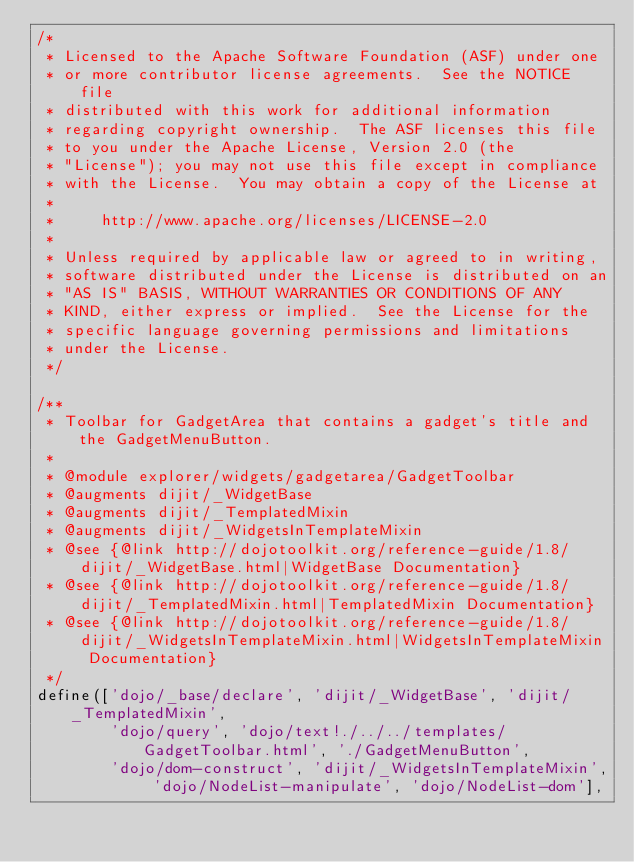Convert code to text. <code><loc_0><loc_0><loc_500><loc_500><_JavaScript_>/*
 * Licensed to the Apache Software Foundation (ASF) under one
 * or more contributor license agreements.  See the NOTICE file
 * distributed with this work for additional information
 * regarding copyright ownership.  The ASF licenses this file
 * to you under the Apache License, Version 2.0 (the
 * "License"); you may not use this file except in compliance
 * with the License.  You may obtain a copy of the License at
 *
 *     http://www.apache.org/licenses/LICENSE-2.0
 *
 * Unless required by applicable law or agreed to in writing,
 * software distributed under the License is distributed on an
 * "AS IS" BASIS, WITHOUT WARRANTIES OR CONDITIONS OF ANY
 * KIND, either express or implied.  See the License for the
 * specific language governing permissions and limitations
 * under the License.
 */

/**
 * Toolbar for GadgetArea that contains a gadget's title and the GadgetMenuButton.
 *
 * @module explorer/widgets/gadgetarea/GadgetToolbar
 * @augments dijit/_WidgetBase
 * @augments dijit/_TemplatedMixin
 * @augments dijit/_WidgetsInTemplateMixin
 * @see {@link http://dojotoolkit.org/reference-guide/1.8/dijit/_WidgetBase.html|WidgetBase Documentation}
 * @see {@link http://dojotoolkit.org/reference-guide/1.8/dijit/_TemplatedMixin.html|TemplatedMixin Documentation}
 * @see {@link http://dojotoolkit.org/reference-guide/1.8/dijit/_WidgetsInTemplateMixin.html|WidgetsInTemplateMixin Documentation}
 */
define(['dojo/_base/declare', 'dijit/_WidgetBase', 'dijit/_TemplatedMixin',
        'dojo/query', 'dojo/text!./../../templates/GadgetToolbar.html', './GadgetMenuButton', 
        'dojo/dom-construct', 'dijit/_WidgetsInTemplateMixin', 'dojo/NodeList-manipulate', 'dojo/NodeList-dom'],</code> 